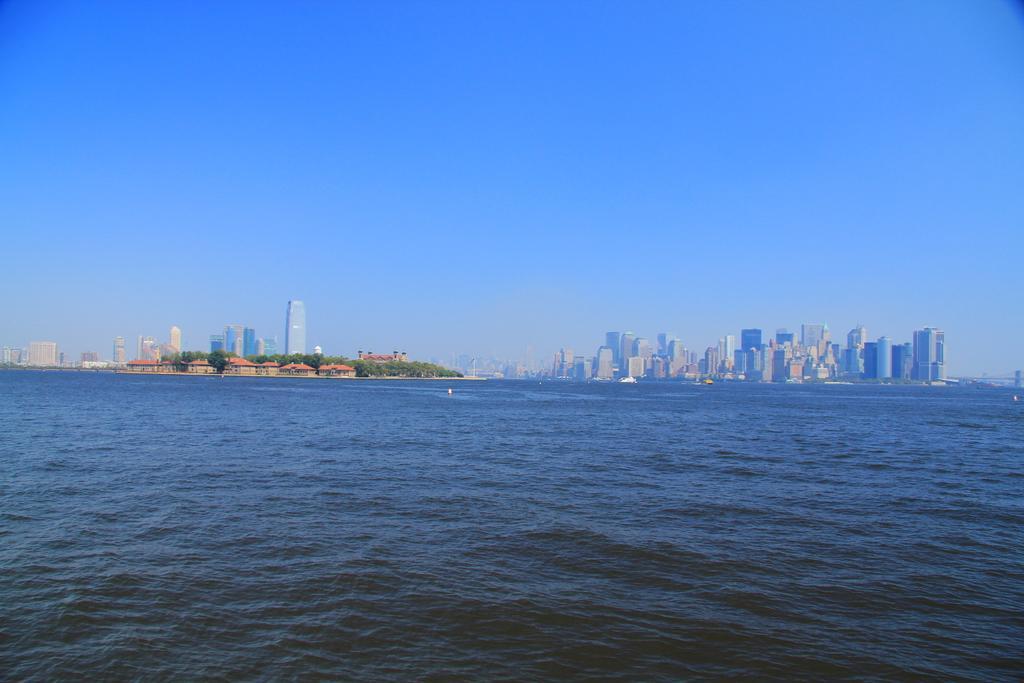Describe this image in one or two sentences. There is water. In the background, there are buildings and trees on the ground and there is blue sky. 